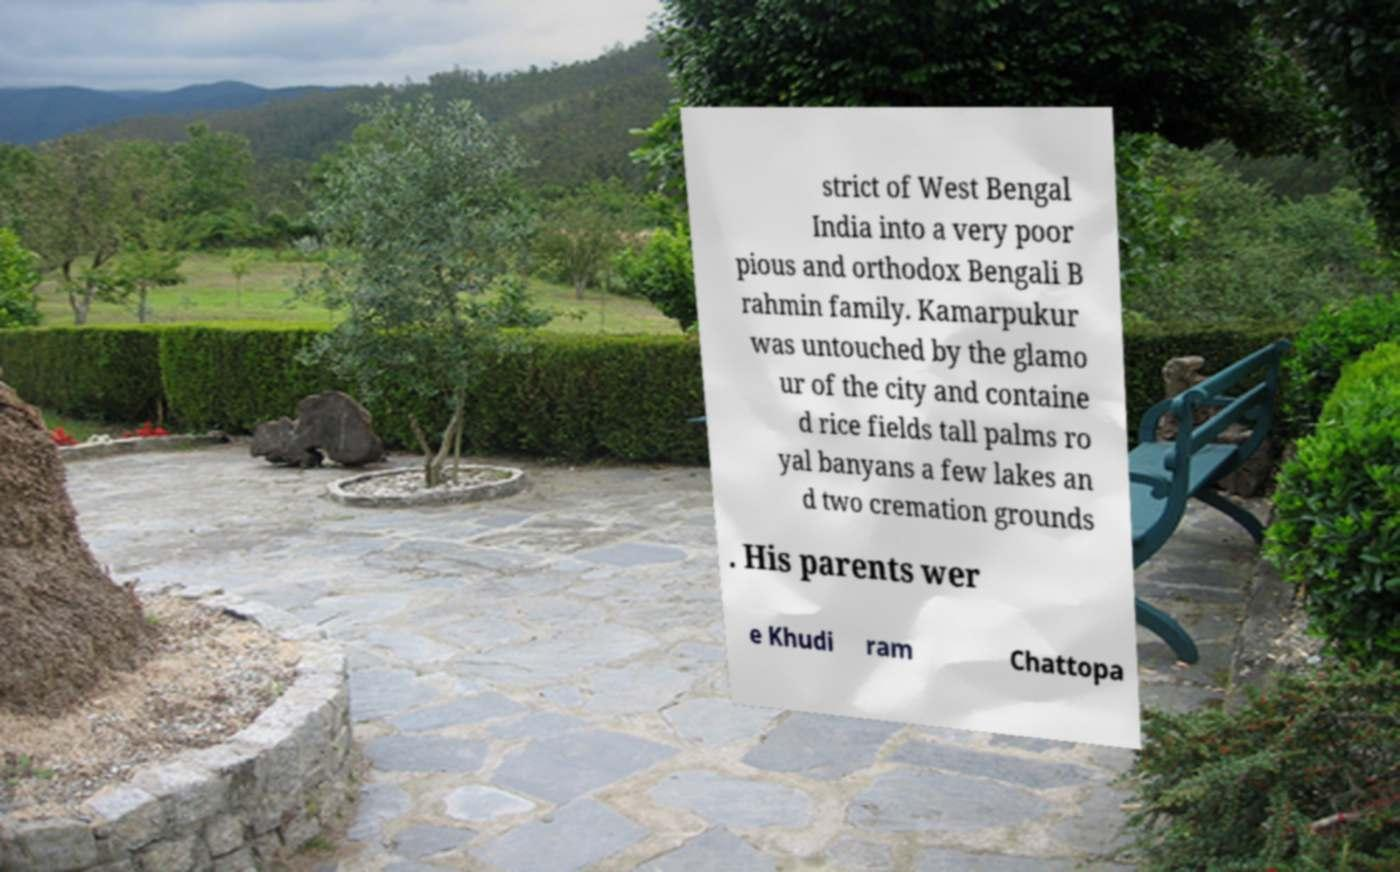Could you extract and type out the text from this image? strict of West Bengal India into a very poor pious and orthodox Bengali B rahmin family. Kamarpukur was untouched by the glamo ur of the city and containe d rice fields tall palms ro yal banyans a few lakes an d two cremation grounds . His parents wer e Khudi ram Chattopa 